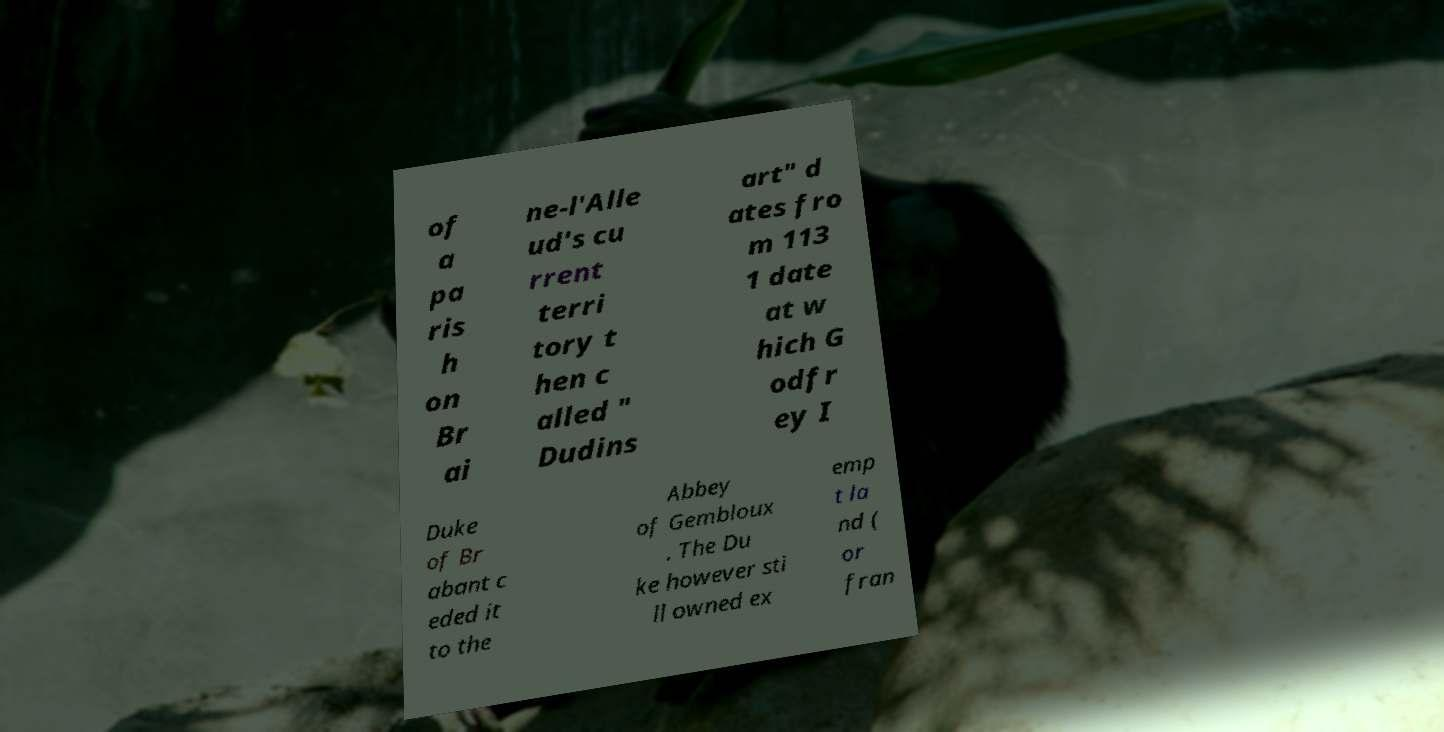Please read and relay the text visible in this image. What does it say? of a pa ris h on Br ai ne-l'Alle ud's cu rrent terri tory t hen c alled " Dudins art" d ates fro m 113 1 date at w hich G odfr ey I Duke of Br abant c eded it to the Abbey of Gembloux . The Du ke however sti ll owned ex emp t la nd ( or fran 